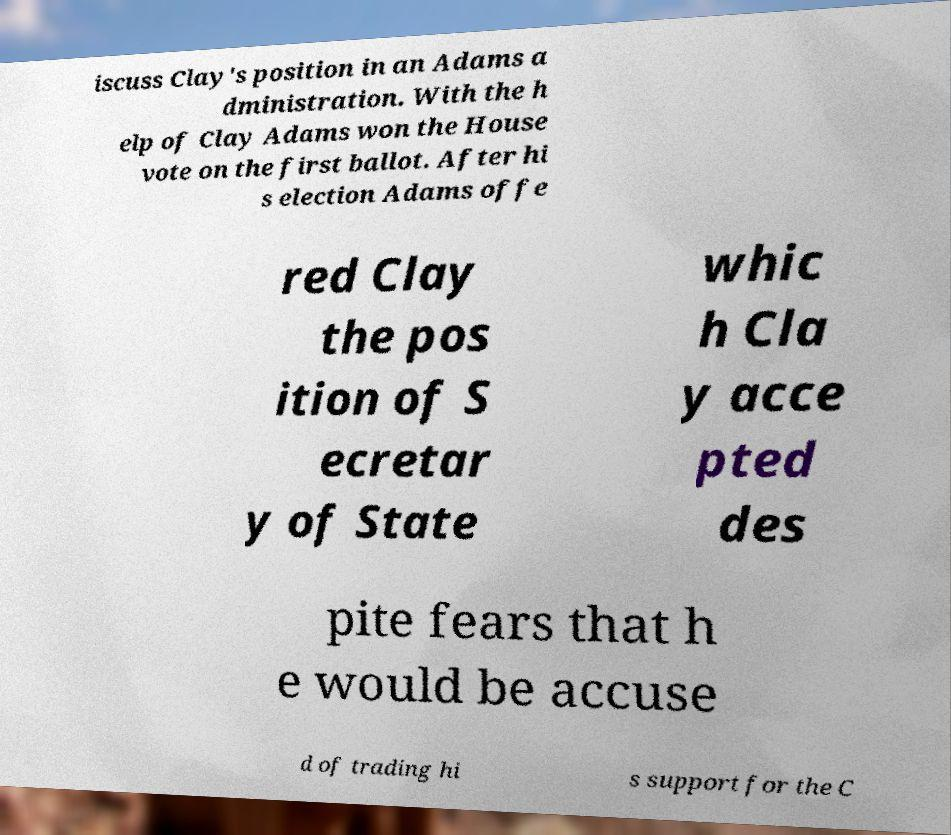Please read and relay the text visible in this image. What does it say? iscuss Clay's position in an Adams a dministration. With the h elp of Clay Adams won the House vote on the first ballot. After hi s election Adams offe red Clay the pos ition of S ecretar y of State whic h Cla y acce pted des pite fears that h e would be accuse d of trading hi s support for the C 